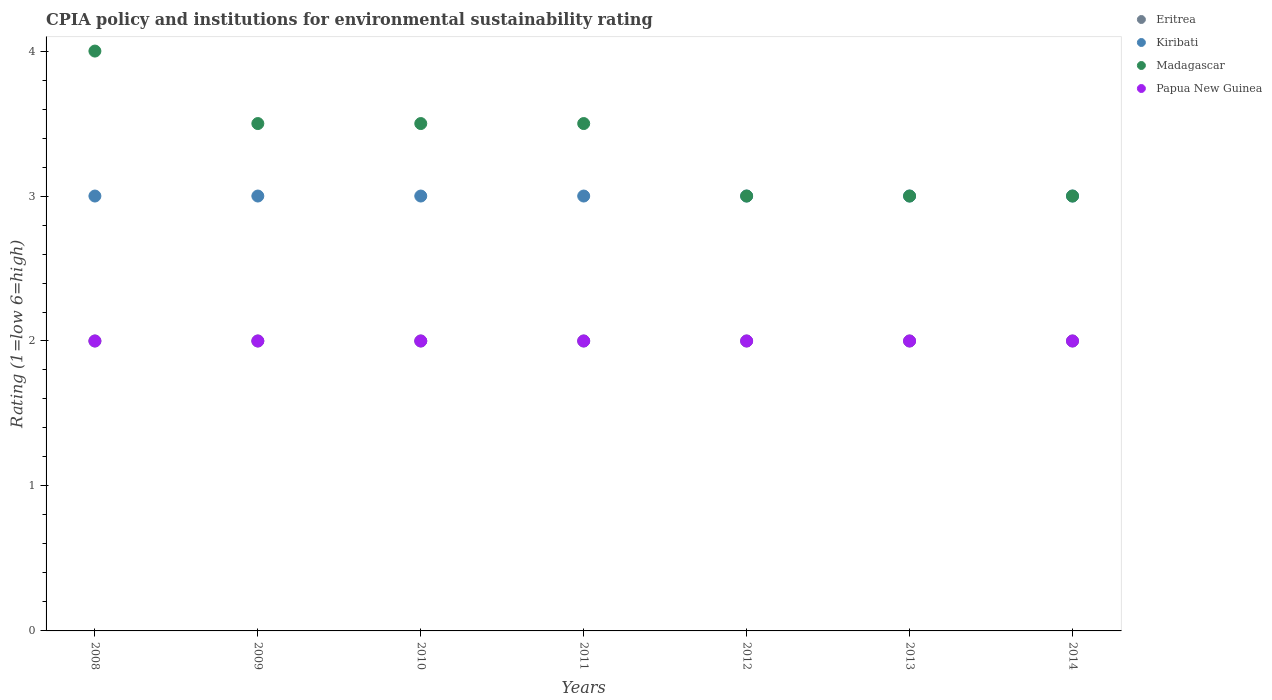What is the CPIA rating in Eritrea in 2009?
Make the answer very short. 2. Across all years, what is the maximum CPIA rating in Eritrea?
Give a very brief answer. 2. Across all years, what is the minimum CPIA rating in Eritrea?
Offer a terse response. 2. What is the average CPIA rating in Madagascar per year?
Provide a short and direct response. 3.36. In how many years, is the CPIA rating in Papua New Guinea greater than 1.6?
Offer a very short reply. 7. What is the ratio of the CPIA rating in Madagascar in 2010 to that in 2014?
Provide a short and direct response. 1.17. Is the difference between the CPIA rating in Madagascar in 2011 and 2012 greater than the difference between the CPIA rating in Papua New Guinea in 2011 and 2012?
Your answer should be compact. Yes. What is the difference between the highest and the second highest CPIA rating in Madagascar?
Give a very brief answer. 0.5. In how many years, is the CPIA rating in Madagascar greater than the average CPIA rating in Madagascar taken over all years?
Your answer should be very brief. 4. Is it the case that in every year, the sum of the CPIA rating in Papua New Guinea and CPIA rating in Eritrea  is greater than the sum of CPIA rating in Kiribati and CPIA rating in Madagascar?
Your answer should be compact. No. Is it the case that in every year, the sum of the CPIA rating in Madagascar and CPIA rating in Kiribati  is greater than the CPIA rating in Eritrea?
Provide a succinct answer. Yes. Is the CPIA rating in Eritrea strictly greater than the CPIA rating in Papua New Guinea over the years?
Give a very brief answer. No. How many years are there in the graph?
Offer a very short reply. 7. What is the difference between two consecutive major ticks on the Y-axis?
Provide a succinct answer. 1. Are the values on the major ticks of Y-axis written in scientific E-notation?
Keep it short and to the point. No. Does the graph contain grids?
Your answer should be compact. No. Where does the legend appear in the graph?
Ensure brevity in your answer.  Top right. What is the title of the graph?
Make the answer very short. CPIA policy and institutions for environmental sustainability rating. Does "Malta" appear as one of the legend labels in the graph?
Keep it short and to the point. No. What is the label or title of the Y-axis?
Keep it short and to the point. Rating (1=low 6=high). What is the Rating (1=low 6=high) in Eritrea in 2008?
Provide a short and direct response. 2. What is the Rating (1=low 6=high) in Madagascar in 2010?
Your answer should be very brief. 3.5. What is the Rating (1=low 6=high) of Kiribati in 2011?
Keep it short and to the point. 3. What is the Rating (1=low 6=high) of Papua New Guinea in 2011?
Give a very brief answer. 2. What is the Rating (1=low 6=high) of Madagascar in 2012?
Make the answer very short. 3. What is the Rating (1=low 6=high) in Kiribati in 2013?
Give a very brief answer. 3. What is the Rating (1=low 6=high) in Eritrea in 2014?
Give a very brief answer. 2. Across all years, what is the maximum Rating (1=low 6=high) of Papua New Guinea?
Give a very brief answer. 2. Across all years, what is the minimum Rating (1=low 6=high) of Kiribati?
Keep it short and to the point. 3. Across all years, what is the minimum Rating (1=low 6=high) of Madagascar?
Your answer should be very brief. 3. Across all years, what is the minimum Rating (1=low 6=high) in Papua New Guinea?
Make the answer very short. 2. What is the total Rating (1=low 6=high) in Kiribati in the graph?
Your answer should be compact. 21. What is the total Rating (1=low 6=high) in Papua New Guinea in the graph?
Your response must be concise. 14. What is the difference between the Rating (1=low 6=high) of Eritrea in 2008 and that in 2009?
Provide a succinct answer. 0. What is the difference between the Rating (1=low 6=high) in Eritrea in 2008 and that in 2010?
Provide a short and direct response. 0. What is the difference between the Rating (1=low 6=high) in Kiribati in 2008 and that in 2010?
Provide a short and direct response. 0. What is the difference between the Rating (1=low 6=high) of Madagascar in 2008 and that in 2010?
Offer a very short reply. 0.5. What is the difference between the Rating (1=low 6=high) in Papua New Guinea in 2008 and that in 2010?
Offer a very short reply. 0. What is the difference between the Rating (1=low 6=high) of Eritrea in 2008 and that in 2011?
Your response must be concise. 0. What is the difference between the Rating (1=low 6=high) of Eritrea in 2008 and that in 2012?
Ensure brevity in your answer.  0. What is the difference between the Rating (1=low 6=high) in Madagascar in 2008 and that in 2012?
Ensure brevity in your answer.  1. What is the difference between the Rating (1=low 6=high) of Kiribati in 2008 and that in 2013?
Your answer should be compact. 0. What is the difference between the Rating (1=low 6=high) in Papua New Guinea in 2008 and that in 2013?
Your answer should be very brief. 0. What is the difference between the Rating (1=low 6=high) of Eritrea in 2008 and that in 2014?
Your answer should be compact. 0. What is the difference between the Rating (1=low 6=high) in Madagascar in 2008 and that in 2014?
Give a very brief answer. 1. What is the difference between the Rating (1=low 6=high) in Papua New Guinea in 2008 and that in 2014?
Give a very brief answer. 0. What is the difference between the Rating (1=low 6=high) in Kiribati in 2009 and that in 2010?
Ensure brevity in your answer.  0. What is the difference between the Rating (1=low 6=high) of Madagascar in 2009 and that in 2010?
Your response must be concise. 0. What is the difference between the Rating (1=low 6=high) of Kiribati in 2009 and that in 2011?
Your response must be concise. 0. What is the difference between the Rating (1=low 6=high) in Eritrea in 2009 and that in 2012?
Your answer should be compact. 0. What is the difference between the Rating (1=low 6=high) in Kiribati in 2009 and that in 2012?
Provide a succinct answer. 0. What is the difference between the Rating (1=low 6=high) in Papua New Guinea in 2009 and that in 2012?
Your response must be concise. 0. What is the difference between the Rating (1=low 6=high) in Kiribati in 2009 and that in 2013?
Give a very brief answer. 0. What is the difference between the Rating (1=low 6=high) of Papua New Guinea in 2009 and that in 2013?
Your response must be concise. 0. What is the difference between the Rating (1=low 6=high) of Papua New Guinea in 2009 and that in 2014?
Offer a very short reply. 0. What is the difference between the Rating (1=low 6=high) in Eritrea in 2010 and that in 2011?
Provide a short and direct response. 0. What is the difference between the Rating (1=low 6=high) in Kiribati in 2010 and that in 2011?
Provide a short and direct response. 0. What is the difference between the Rating (1=low 6=high) of Papua New Guinea in 2010 and that in 2011?
Make the answer very short. 0. What is the difference between the Rating (1=low 6=high) of Eritrea in 2010 and that in 2012?
Your answer should be very brief. 0. What is the difference between the Rating (1=low 6=high) of Kiribati in 2010 and that in 2012?
Provide a short and direct response. 0. What is the difference between the Rating (1=low 6=high) of Eritrea in 2010 and that in 2014?
Provide a succinct answer. 0. What is the difference between the Rating (1=low 6=high) of Madagascar in 2010 and that in 2014?
Provide a succinct answer. 0.5. What is the difference between the Rating (1=low 6=high) in Papua New Guinea in 2010 and that in 2014?
Provide a short and direct response. 0. What is the difference between the Rating (1=low 6=high) of Eritrea in 2011 and that in 2012?
Provide a succinct answer. 0. What is the difference between the Rating (1=low 6=high) of Kiribati in 2011 and that in 2012?
Offer a very short reply. 0. What is the difference between the Rating (1=low 6=high) of Papua New Guinea in 2011 and that in 2012?
Keep it short and to the point. 0. What is the difference between the Rating (1=low 6=high) in Kiribati in 2011 and that in 2013?
Keep it short and to the point. 0. What is the difference between the Rating (1=low 6=high) of Eritrea in 2011 and that in 2014?
Give a very brief answer. 0. What is the difference between the Rating (1=low 6=high) of Kiribati in 2011 and that in 2014?
Provide a succinct answer. 0. What is the difference between the Rating (1=low 6=high) of Madagascar in 2011 and that in 2014?
Provide a short and direct response. 0.5. What is the difference between the Rating (1=low 6=high) of Madagascar in 2012 and that in 2013?
Keep it short and to the point. 0. What is the difference between the Rating (1=low 6=high) of Eritrea in 2012 and that in 2014?
Make the answer very short. 0. What is the difference between the Rating (1=low 6=high) of Kiribati in 2012 and that in 2014?
Your answer should be compact. 0. What is the difference between the Rating (1=low 6=high) of Madagascar in 2012 and that in 2014?
Keep it short and to the point. 0. What is the difference between the Rating (1=low 6=high) in Papua New Guinea in 2012 and that in 2014?
Your answer should be very brief. 0. What is the difference between the Rating (1=low 6=high) in Eritrea in 2013 and that in 2014?
Make the answer very short. 0. What is the difference between the Rating (1=low 6=high) in Kiribati in 2013 and that in 2014?
Provide a short and direct response. 0. What is the difference between the Rating (1=low 6=high) of Eritrea in 2008 and the Rating (1=low 6=high) of Kiribati in 2009?
Your response must be concise. -1. What is the difference between the Rating (1=low 6=high) of Eritrea in 2008 and the Rating (1=low 6=high) of Papua New Guinea in 2009?
Your response must be concise. 0. What is the difference between the Rating (1=low 6=high) in Eritrea in 2008 and the Rating (1=low 6=high) in Kiribati in 2010?
Provide a succinct answer. -1. What is the difference between the Rating (1=low 6=high) in Madagascar in 2008 and the Rating (1=low 6=high) in Papua New Guinea in 2010?
Provide a succinct answer. 2. What is the difference between the Rating (1=low 6=high) in Kiribati in 2008 and the Rating (1=low 6=high) in Madagascar in 2011?
Offer a terse response. -0.5. What is the difference between the Rating (1=low 6=high) of Eritrea in 2008 and the Rating (1=low 6=high) of Kiribati in 2012?
Give a very brief answer. -1. What is the difference between the Rating (1=low 6=high) of Eritrea in 2008 and the Rating (1=low 6=high) of Papua New Guinea in 2012?
Your answer should be very brief. 0. What is the difference between the Rating (1=low 6=high) of Kiribati in 2008 and the Rating (1=low 6=high) of Madagascar in 2012?
Keep it short and to the point. 0. What is the difference between the Rating (1=low 6=high) of Kiribati in 2008 and the Rating (1=low 6=high) of Papua New Guinea in 2012?
Give a very brief answer. 1. What is the difference between the Rating (1=low 6=high) of Madagascar in 2008 and the Rating (1=low 6=high) of Papua New Guinea in 2012?
Offer a terse response. 2. What is the difference between the Rating (1=low 6=high) in Eritrea in 2008 and the Rating (1=low 6=high) in Kiribati in 2013?
Offer a very short reply. -1. What is the difference between the Rating (1=low 6=high) of Eritrea in 2008 and the Rating (1=low 6=high) of Papua New Guinea in 2013?
Keep it short and to the point. 0. What is the difference between the Rating (1=low 6=high) in Kiribati in 2008 and the Rating (1=low 6=high) in Madagascar in 2014?
Your answer should be compact. 0. What is the difference between the Rating (1=low 6=high) of Kiribati in 2008 and the Rating (1=low 6=high) of Papua New Guinea in 2014?
Provide a succinct answer. 1. What is the difference between the Rating (1=low 6=high) of Eritrea in 2009 and the Rating (1=low 6=high) of Kiribati in 2010?
Give a very brief answer. -1. What is the difference between the Rating (1=low 6=high) in Kiribati in 2009 and the Rating (1=low 6=high) in Madagascar in 2010?
Your response must be concise. -0.5. What is the difference between the Rating (1=low 6=high) in Madagascar in 2009 and the Rating (1=low 6=high) in Papua New Guinea in 2010?
Offer a very short reply. 1.5. What is the difference between the Rating (1=low 6=high) in Eritrea in 2009 and the Rating (1=low 6=high) in Kiribati in 2011?
Offer a very short reply. -1. What is the difference between the Rating (1=low 6=high) in Eritrea in 2009 and the Rating (1=low 6=high) in Madagascar in 2011?
Your answer should be compact. -1.5. What is the difference between the Rating (1=low 6=high) in Eritrea in 2009 and the Rating (1=low 6=high) in Papua New Guinea in 2011?
Give a very brief answer. 0. What is the difference between the Rating (1=low 6=high) in Kiribati in 2009 and the Rating (1=low 6=high) in Madagascar in 2011?
Your answer should be compact. -0.5. What is the difference between the Rating (1=low 6=high) in Madagascar in 2009 and the Rating (1=low 6=high) in Papua New Guinea in 2011?
Keep it short and to the point. 1.5. What is the difference between the Rating (1=low 6=high) in Eritrea in 2009 and the Rating (1=low 6=high) in Kiribati in 2012?
Keep it short and to the point. -1. What is the difference between the Rating (1=low 6=high) of Eritrea in 2009 and the Rating (1=low 6=high) of Madagascar in 2012?
Your answer should be compact. -1. What is the difference between the Rating (1=low 6=high) of Eritrea in 2009 and the Rating (1=low 6=high) of Papua New Guinea in 2012?
Your answer should be very brief. 0. What is the difference between the Rating (1=low 6=high) in Madagascar in 2009 and the Rating (1=low 6=high) in Papua New Guinea in 2012?
Your response must be concise. 1.5. What is the difference between the Rating (1=low 6=high) in Kiribati in 2009 and the Rating (1=low 6=high) in Papua New Guinea in 2013?
Your response must be concise. 1. What is the difference between the Rating (1=low 6=high) of Kiribati in 2009 and the Rating (1=low 6=high) of Papua New Guinea in 2014?
Offer a terse response. 1. What is the difference between the Rating (1=low 6=high) in Madagascar in 2009 and the Rating (1=low 6=high) in Papua New Guinea in 2014?
Give a very brief answer. 1.5. What is the difference between the Rating (1=low 6=high) in Eritrea in 2010 and the Rating (1=low 6=high) in Madagascar in 2011?
Your response must be concise. -1.5. What is the difference between the Rating (1=low 6=high) of Kiribati in 2010 and the Rating (1=low 6=high) of Papua New Guinea in 2011?
Your answer should be very brief. 1. What is the difference between the Rating (1=low 6=high) in Madagascar in 2010 and the Rating (1=low 6=high) in Papua New Guinea in 2011?
Provide a succinct answer. 1.5. What is the difference between the Rating (1=low 6=high) of Eritrea in 2010 and the Rating (1=low 6=high) of Kiribati in 2012?
Offer a terse response. -1. What is the difference between the Rating (1=low 6=high) in Kiribati in 2010 and the Rating (1=low 6=high) in Madagascar in 2012?
Provide a short and direct response. 0. What is the difference between the Rating (1=low 6=high) in Kiribati in 2010 and the Rating (1=low 6=high) in Papua New Guinea in 2012?
Provide a short and direct response. 1. What is the difference between the Rating (1=low 6=high) in Madagascar in 2010 and the Rating (1=low 6=high) in Papua New Guinea in 2012?
Offer a terse response. 1.5. What is the difference between the Rating (1=low 6=high) in Eritrea in 2010 and the Rating (1=low 6=high) in Kiribati in 2013?
Keep it short and to the point. -1. What is the difference between the Rating (1=low 6=high) in Eritrea in 2010 and the Rating (1=low 6=high) in Madagascar in 2013?
Make the answer very short. -1. What is the difference between the Rating (1=low 6=high) in Eritrea in 2010 and the Rating (1=low 6=high) in Papua New Guinea in 2014?
Your response must be concise. 0. What is the difference between the Rating (1=low 6=high) of Kiribati in 2010 and the Rating (1=low 6=high) of Madagascar in 2014?
Ensure brevity in your answer.  0. What is the difference between the Rating (1=low 6=high) in Kiribati in 2010 and the Rating (1=low 6=high) in Papua New Guinea in 2014?
Keep it short and to the point. 1. What is the difference between the Rating (1=low 6=high) of Madagascar in 2010 and the Rating (1=low 6=high) of Papua New Guinea in 2014?
Ensure brevity in your answer.  1.5. What is the difference between the Rating (1=low 6=high) of Eritrea in 2011 and the Rating (1=low 6=high) of Madagascar in 2012?
Give a very brief answer. -1. What is the difference between the Rating (1=low 6=high) of Eritrea in 2011 and the Rating (1=low 6=high) of Papua New Guinea in 2012?
Provide a short and direct response. 0. What is the difference between the Rating (1=low 6=high) of Kiribati in 2011 and the Rating (1=low 6=high) of Madagascar in 2012?
Your answer should be compact. 0. What is the difference between the Rating (1=low 6=high) in Madagascar in 2011 and the Rating (1=low 6=high) in Papua New Guinea in 2012?
Provide a succinct answer. 1.5. What is the difference between the Rating (1=low 6=high) in Eritrea in 2011 and the Rating (1=low 6=high) in Madagascar in 2013?
Provide a succinct answer. -1. What is the difference between the Rating (1=low 6=high) of Kiribati in 2011 and the Rating (1=low 6=high) of Madagascar in 2013?
Provide a short and direct response. 0. What is the difference between the Rating (1=low 6=high) of Madagascar in 2011 and the Rating (1=low 6=high) of Papua New Guinea in 2013?
Your response must be concise. 1.5. What is the difference between the Rating (1=low 6=high) of Eritrea in 2011 and the Rating (1=low 6=high) of Kiribati in 2014?
Provide a succinct answer. -1. What is the difference between the Rating (1=low 6=high) in Eritrea in 2011 and the Rating (1=low 6=high) in Madagascar in 2014?
Your answer should be compact. -1. What is the difference between the Rating (1=low 6=high) in Kiribati in 2011 and the Rating (1=low 6=high) in Madagascar in 2014?
Your answer should be very brief. 0. What is the difference between the Rating (1=low 6=high) of Madagascar in 2011 and the Rating (1=low 6=high) of Papua New Guinea in 2014?
Offer a very short reply. 1.5. What is the difference between the Rating (1=low 6=high) of Eritrea in 2012 and the Rating (1=low 6=high) of Kiribati in 2013?
Keep it short and to the point. -1. What is the difference between the Rating (1=low 6=high) in Eritrea in 2012 and the Rating (1=low 6=high) in Madagascar in 2013?
Give a very brief answer. -1. What is the difference between the Rating (1=low 6=high) in Eritrea in 2012 and the Rating (1=low 6=high) in Papua New Guinea in 2013?
Offer a terse response. 0. What is the difference between the Rating (1=low 6=high) in Kiribati in 2012 and the Rating (1=low 6=high) in Madagascar in 2013?
Your answer should be very brief. 0. What is the difference between the Rating (1=low 6=high) of Eritrea in 2012 and the Rating (1=low 6=high) of Madagascar in 2014?
Your answer should be very brief. -1. What is the difference between the Rating (1=low 6=high) of Eritrea in 2013 and the Rating (1=low 6=high) of Papua New Guinea in 2014?
Provide a short and direct response. 0. What is the difference between the Rating (1=low 6=high) of Kiribati in 2013 and the Rating (1=low 6=high) of Papua New Guinea in 2014?
Offer a very short reply. 1. What is the difference between the Rating (1=low 6=high) of Madagascar in 2013 and the Rating (1=low 6=high) of Papua New Guinea in 2014?
Offer a very short reply. 1. What is the average Rating (1=low 6=high) in Kiribati per year?
Your answer should be very brief. 3. What is the average Rating (1=low 6=high) of Madagascar per year?
Your response must be concise. 3.36. What is the average Rating (1=low 6=high) of Papua New Guinea per year?
Provide a short and direct response. 2. In the year 2008, what is the difference between the Rating (1=low 6=high) of Eritrea and Rating (1=low 6=high) of Kiribati?
Your response must be concise. -1. In the year 2008, what is the difference between the Rating (1=low 6=high) in Kiribati and Rating (1=low 6=high) in Madagascar?
Make the answer very short. -1. In the year 2008, what is the difference between the Rating (1=low 6=high) of Kiribati and Rating (1=low 6=high) of Papua New Guinea?
Keep it short and to the point. 1. In the year 2008, what is the difference between the Rating (1=low 6=high) in Madagascar and Rating (1=low 6=high) in Papua New Guinea?
Provide a short and direct response. 2. In the year 2009, what is the difference between the Rating (1=low 6=high) in Eritrea and Rating (1=low 6=high) in Madagascar?
Your answer should be very brief. -1.5. In the year 2009, what is the difference between the Rating (1=low 6=high) of Eritrea and Rating (1=low 6=high) of Papua New Guinea?
Your answer should be very brief. 0. In the year 2009, what is the difference between the Rating (1=low 6=high) of Kiribati and Rating (1=low 6=high) of Madagascar?
Keep it short and to the point. -0.5. In the year 2009, what is the difference between the Rating (1=low 6=high) of Kiribati and Rating (1=low 6=high) of Papua New Guinea?
Provide a short and direct response. 1. In the year 2010, what is the difference between the Rating (1=low 6=high) in Eritrea and Rating (1=low 6=high) in Kiribati?
Your answer should be very brief. -1. In the year 2010, what is the difference between the Rating (1=low 6=high) of Eritrea and Rating (1=low 6=high) of Madagascar?
Provide a short and direct response. -1.5. In the year 2010, what is the difference between the Rating (1=low 6=high) in Eritrea and Rating (1=low 6=high) in Papua New Guinea?
Your response must be concise. 0. In the year 2010, what is the difference between the Rating (1=low 6=high) in Kiribati and Rating (1=low 6=high) in Papua New Guinea?
Give a very brief answer. 1. In the year 2010, what is the difference between the Rating (1=low 6=high) of Madagascar and Rating (1=low 6=high) of Papua New Guinea?
Give a very brief answer. 1.5. In the year 2011, what is the difference between the Rating (1=low 6=high) in Eritrea and Rating (1=low 6=high) in Kiribati?
Your answer should be very brief. -1. In the year 2011, what is the difference between the Rating (1=low 6=high) of Eritrea and Rating (1=low 6=high) of Papua New Guinea?
Your answer should be compact. 0. In the year 2011, what is the difference between the Rating (1=low 6=high) in Kiribati and Rating (1=low 6=high) in Madagascar?
Provide a succinct answer. -0.5. In the year 2011, what is the difference between the Rating (1=low 6=high) in Kiribati and Rating (1=low 6=high) in Papua New Guinea?
Your answer should be very brief. 1. In the year 2011, what is the difference between the Rating (1=low 6=high) in Madagascar and Rating (1=low 6=high) in Papua New Guinea?
Your answer should be very brief. 1.5. In the year 2012, what is the difference between the Rating (1=low 6=high) in Eritrea and Rating (1=low 6=high) in Kiribati?
Your response must be concise. -1. In the year 2012, what is the difference between the Rating (1=low 6=high) in Eritrea and Rating (1=low 6=high) in Madagascar?
Make the answer very short. -1. In the year 2012, what is the difference between the Rating (1=low 6=high) in Kiribati and Rating (1=low 6=high) in Madagascar?
Make the answer very short. 0. In the year 2014, what is the difference between the Rating (1=low 6=high) in Eritrea and Rating (1=low 6=high) in Madagascar?
Ensure brevity in your answer.  -1. In the year 2014, what is the difference between the Rating (1=low 6=high) in Kiribati and Rating (1=low 6=high) in Papua New Guinea?
Keep it short and to the point. 1. What is the ratio of the Rating (1=low 6=high) of Madagascar in 2008 to that in 2009?
Provide a succinct answer. 1.14. What is the ratio of the Rating (1=low 6=high) of Eritrea in 2008 to that in 2010?
Offer a very short reply. 1. What is the ratio of the Rating (1=low 6=high) of Madagascar in 2008 to that in 2011?
Keep it short and to the point. 1.14. What is the ratio of the Rating (1=low 6=high) in Eritrea in 2008 to that in 2012?
Make the answer very short. 1. What is the ratio of the Rating (1=low 6=high) of Kiribati in 2008 to that in 2012?
Your response must be concise. 1. What is the ratio of the Rating (1=low 6=high) of Madagascar in 2008 to that in 2012?
Your response must be concise. 1.33. What is the ratio of the Rating (1=low 6=high) in Eritrea in 2008 to that in 2013?
Your answer should be very brief. 1. What is the ratio of the Rating (1=low 6=high) in Papua New Guinea in 2008 to that in 2013?
Your answer should be very brief. 1. What is the ratio of the Rating (1=low 6=high) in Madagascar in 2008 to that in 2014?
Provide a short and direct response. 1.33. What is the ratio of the Rating (1=low 6=high) in Madagascar in 2009 to that in 2010?
Give a very brief answer. 1. What is the ratio of the Rating (1=low 6=high) of Papua New Guinea in 2009 to that in 2010?
Provide a short and direct response. 1. What is the ratio of the Rating (1=low 6=high) of Eritrea in 2009 to that in 2011?
Make the answer very short. 1. What is the ratio of the Rating (1=low 6=high) in Kiribati in 2009 to that in 2011?
Your answer should be very brief. 1. What is the ratio of the Rating (1=low 6=high) in Madagascar in 2009 to that in 2011?
Provide a succinct answer. 1. What is the ratio of the Rating (1=low 6=high) of Madagascar in 2009 to that in 2012?
Your answer should be very brief. 1.17. What is the ratio of the Rating (1=low 6=high) in Kiribati in 2009 to that in 2013?
Provide a succinct answer. 1. What is the ratio of the Rating (1=low 6=high) of Madagascar in 2009 to that in 2013?
Your answer should be very brief. 1.17. What is the ratio of the Rating (1=low 6=high) of Papua New Guinea in 2009 to that in 2013?
Keep it short and to the point. 1. What is the ratio of the Rating (1=low 6=high) in Kiribati in 2009 to that in 2014?
Provide a succinct answer. 1. What is the ratio of the Rating (1=low 6=high) in Madagascar in 2009 to that in 2014?
Keep it short and to the point. 1.17. What is the ratio of the Rating (1=low 6=high) in Kiribati in 2010 to that in 2011?
Your answer should be very brief. 1. What is the ratio of the Rating (1=low 6=high) in Papua New Guinea in 2010 to that in 2011?
Your answer should be compact. 1. What is the ratio of the Rating (1=low 6=high) of Eritrea in 2010 to that in 2012?
Make the answer very short. 1. What is the ratio of the Rating (1=low 6=high) in Kiribati in 2010 to that in 2012?
Make the answer very short. 1. What is the ratio of the Rating (1=low 6=high) in Madagascar in 2010 to that in 2012?
Provide a succinct answer. 1.17. What is the ratio of the Rating (1=low 6=high) in Papua New Guinea in 2010 to that in 2012?
Offer a terse response. 1. What is the ratio of the Rating (1=low 6=high) in Madagascar in 2010 to that in 2013?
Provide a succinct answer. 1.17. What is the ratio of the Rating (1=low 6=high) in Papua New Guinea in 2010 to that in 2013?
Provide a succinct answer. 1. What is the ratio of the Rating (1=low 6=high) in Papua New Guinea in 2010 to that in 2014?
Provide a succinct answer. 1. What is the ratio of the Rating (1=low 6=high) in Papua New Guinea in 2011 to that in 2012?
Make the answer very short. 1. What is the ratio of the Rating (1=low 6=high) of Kiribati in 2011 to that in 2013?
Provide a short and direct response. 1. What is the ratio of the Rating (1=low 6=high) of Eritrea in 2011 to that in 2014?
Offer a terse response. 1. What is the ratio of the Rating (1=low 6=high) in Papua New Guinea in 2011 to that in 2014?
Your answer should be very brief. 1. What is the ratio of the Rating (1=low 6=high) in Madagascar in 2012 to that in 2013?
Your answer should be compact. 1. What is the ratio of the Rating (1=low 6=high) of Eritrea in 2012 to that in 2014?
Ensure brevity in your answer.  1. What is the ratio of the Rating (1=low 6=high) of Kiribati in 2013 to that in 2014?
Make the answer very short. 1. What is the ratio of the Rating (1=low 6=high) in Madagascar in 2013 to that in 2014?
Your answer should be compact. 1. What is the ratio of the Rating (1=low 6=high) of Papua New Guinea in 2013 to that in 2014?
Provide a succinct answer. 1. What is the difference between the highest and the second highest Rating (1=low 6=high) of Eritrea?
Offer a very short reply. 0. What is the difference between the highest and the second highest Rating (1=low 6=high) of Papua New Guinea?
Offer a very short reply. 0. What is the difference between the highest and the lowest Rating (1=low 6=high) in Kiribati?
Your answer should be very brief. 0. What is the difference between the highest and the lowest Rating (1=low 6=high) in Madagascar?
Provide a succinct answer. 1. 